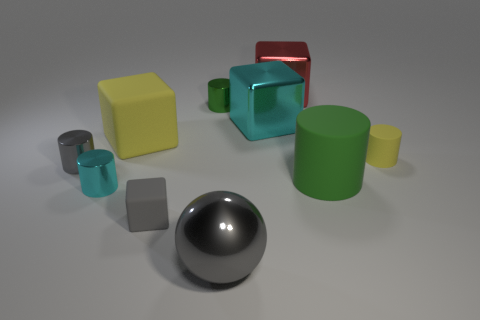Subtract all cyan cylinders. How many cylinders are left? 4 Subtract all large green cylinders. How many cylinders are left? 4 Subtract all red cylinders. Subtract all cyan balls. How many cylinders are left? 5 Subtract all balls. How many objects are left? 9 Add 5 large gray metallic things. How many large gray metallic things exist? 6 Subtract 1 gray cylinders. How many objects are left? 9 Subtract all large cyan objects. Subtract all rubber spheres. How many objects are left? 9 Add 7 cyan blocks. How many cyan blocks are left? 8 